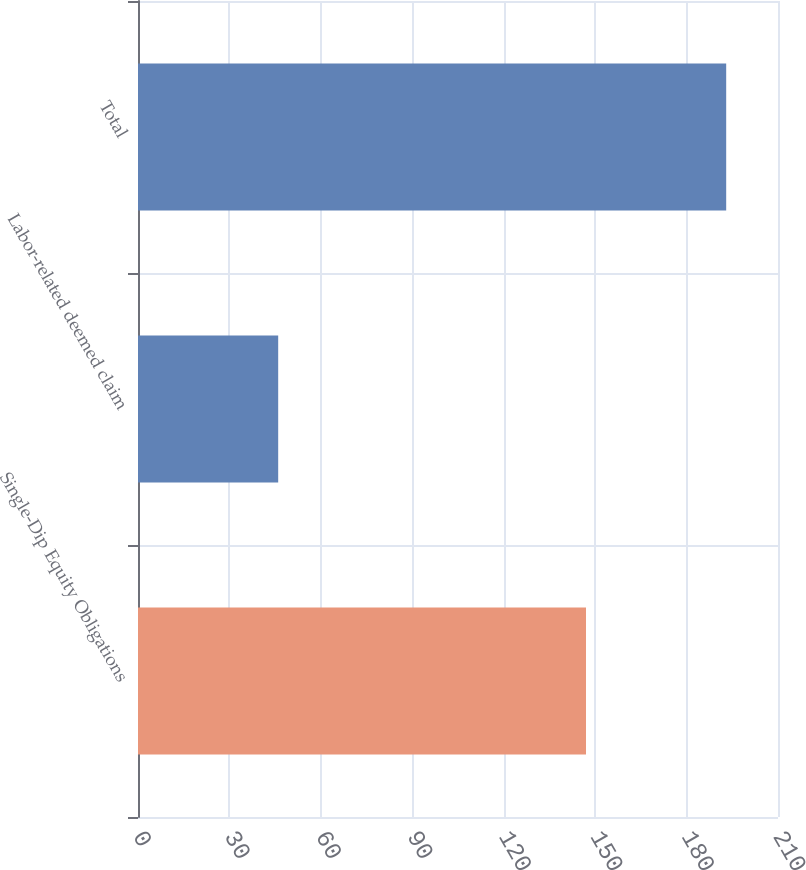<chart> <loc_0><loc_0><loc_500><loc_500><bar_chart><fcel>Single-Dip Equity Obligations<fcel>Labor-related deemed claim<fcel>Total<nl><fcel>147<fcel>46<fcel>193<nl></chart> 